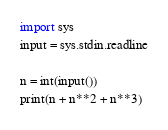<code> <loc_0><loc_0><loc_500><loc_500><_Python_>import sys
input = sys.stdin.readline

n = int(input())
print(n + n**2 + n**3)
</code> 